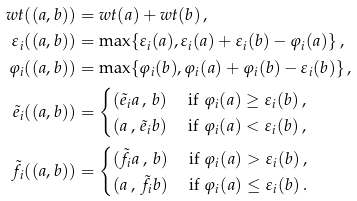Convert formula to latex. <formula><loc_0><loc_0><loc_500><loc_500>w t ( ( a , b ) ) & = w t ( a ) + w t ( b ) \, , \\ \varepsilon _ { i } ( ( a , b ) ) & = \max \{ \varepsilon _ { i } ( a ) , \varepsilon _ { i } ( a ) + \varepsilon _ { i } ( b ) - \varphi _ { i } ( a ) \} \, , \\ \varphi _ { i } ( ( a , b ) ) & = \max \{ \varphi _ { i } ( b ) , \varphi _ { i } ( a ) + \varphi _ { i } ( b ) - \varepsilon _ { i } ( b ) \} \, , \\ \tilde { e } _ { i } ( ( a , b ) ) & = \begin{cases} ( \tilde { e } _ { i } a \, , \, b ) & \text { if } \varphi _ { i } ( a ) \geq \varepsilon _ { i } ( b ) \, , \\ ( a \, , \, \tilde { e } _ { i } b ) & \text { if } \varphi _ { i } ( a ) < \varepsilon _ { i } ( b ) \, , \end{cases} \\ \tilde { f } _ { i } ( ( a , b ) ) & = \begin{cases} ( \tilde { f } _ { i } a \, , \, b ) & \text { if } \varphi _ { i } ( a ) > \varepsilon _ { i } ( b ) \, , \\ ( a \, , \, \tilde { f } _ { i } b ) & \text { if } \varphi _ { i } ( a ) \leq \varepsilon _ { i } ( b ) \, . \end{cases}</formula> 